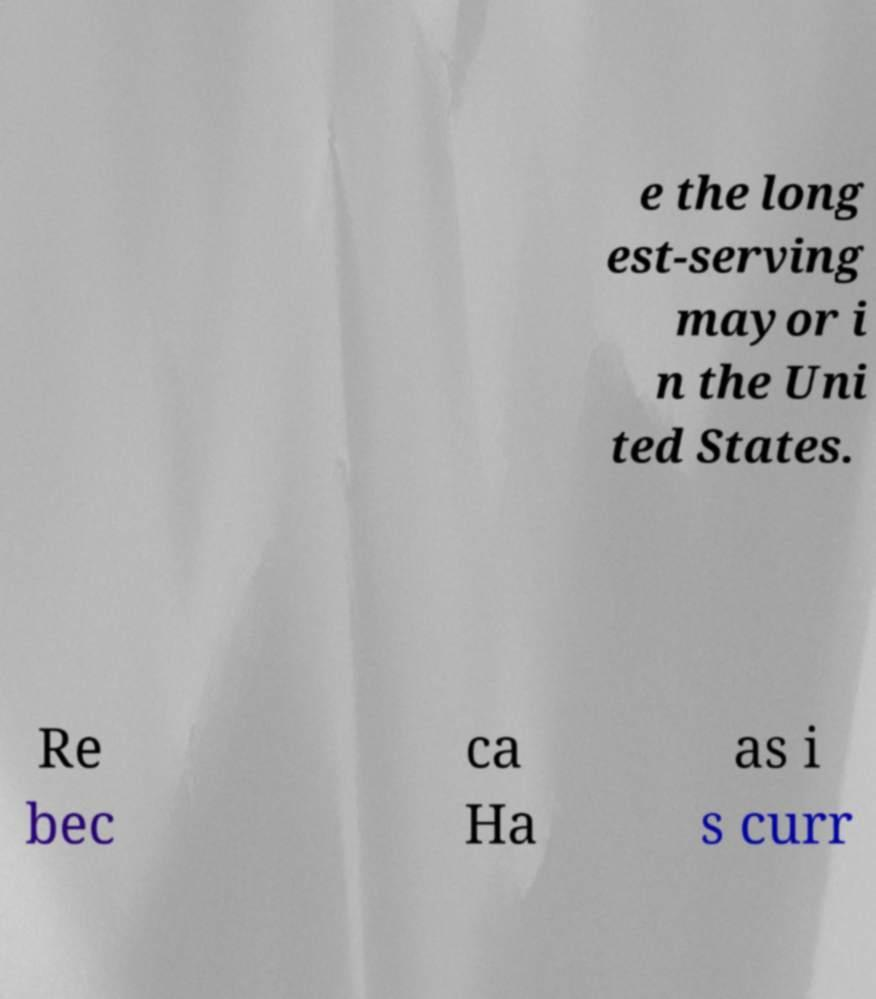What messages or text are displayed in this image? I need them in a readable, typed format. e the long est-serving mayor i n the Uni ted States. Re bec ca Ha as i s curr 